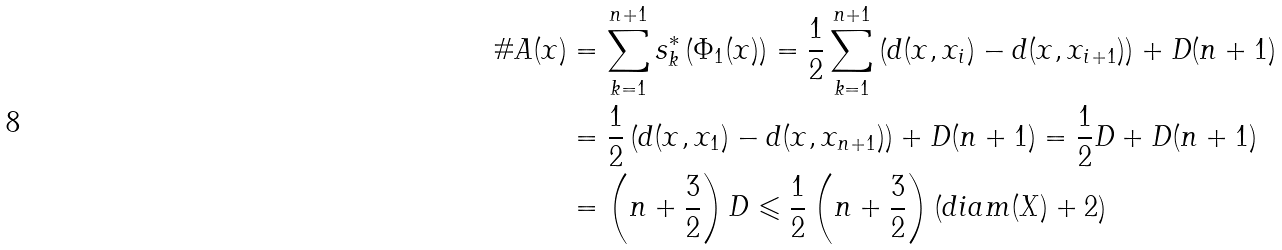<formula> <loc_0><loc_0><loc_500><loc_500>\# A ( x ) & = \sum _ { k = 1 } ^ { n + 1 } s _ { k } ^ { * } \left ( \Phi _ { 1 } ( x ) \right ) = \frac { 1 } { 2 } \sum _ { k = 1 } ^ { n + 1 } \left ( d ( x , x _ { i } ) - d ( x , x _ { i + 1 } ) \right ) + D ( n + 1 ) \\ & = \frac { 1 } { 2 } \left ( d ( x , x _ { 1 } ) - d ( x , x _ { n + 1 } ) \right ) + D ( n + 1 ) = \frac { 1 } { 2 } D + D ( n + 1 ) \\ & = \left ( n + \frac { 3 } { 2 } \right ) D \leqslant \frac { 1 } { 2 } \left ( n + \frac { 3 } { 2 } \right ) \left ( d i a m ( X ) + 2 \right )</formula> 